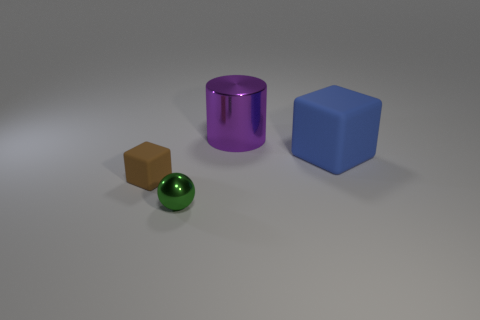Add 4 tiny matte things. How many objects exist? 8 Subtract all balls. How many objects are left? 3 Add 4 small things. How many small things are left? 6 Add 2 small green metallic spheres. How many small green metallic spheres exist? 3 Subtract 0 blue cylinders. How many objects are left? 4 Subtract all small brown metallic cylinders. Subtract all small brown rubber blocks. How many objects are left? 3 